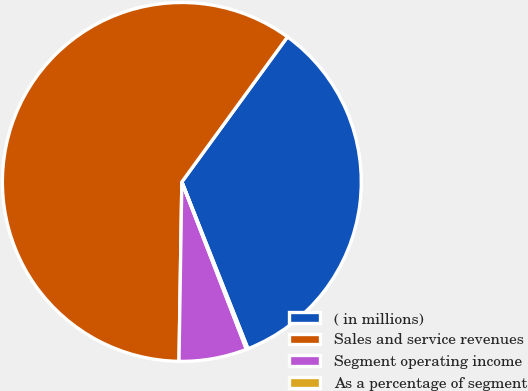Convert chart to OTSL. <chart><loc_0><loc_0><loc_500><loc_500><pie_chart><fcel>( in millions)<fcel>Sales and service revenues<fcel>Segment operating income<fcel>As a percentage of segment<nl><fcel>33.97%<fcel>59.76%<fcel>6.11%<fcel>0.15%<nl></chart> 